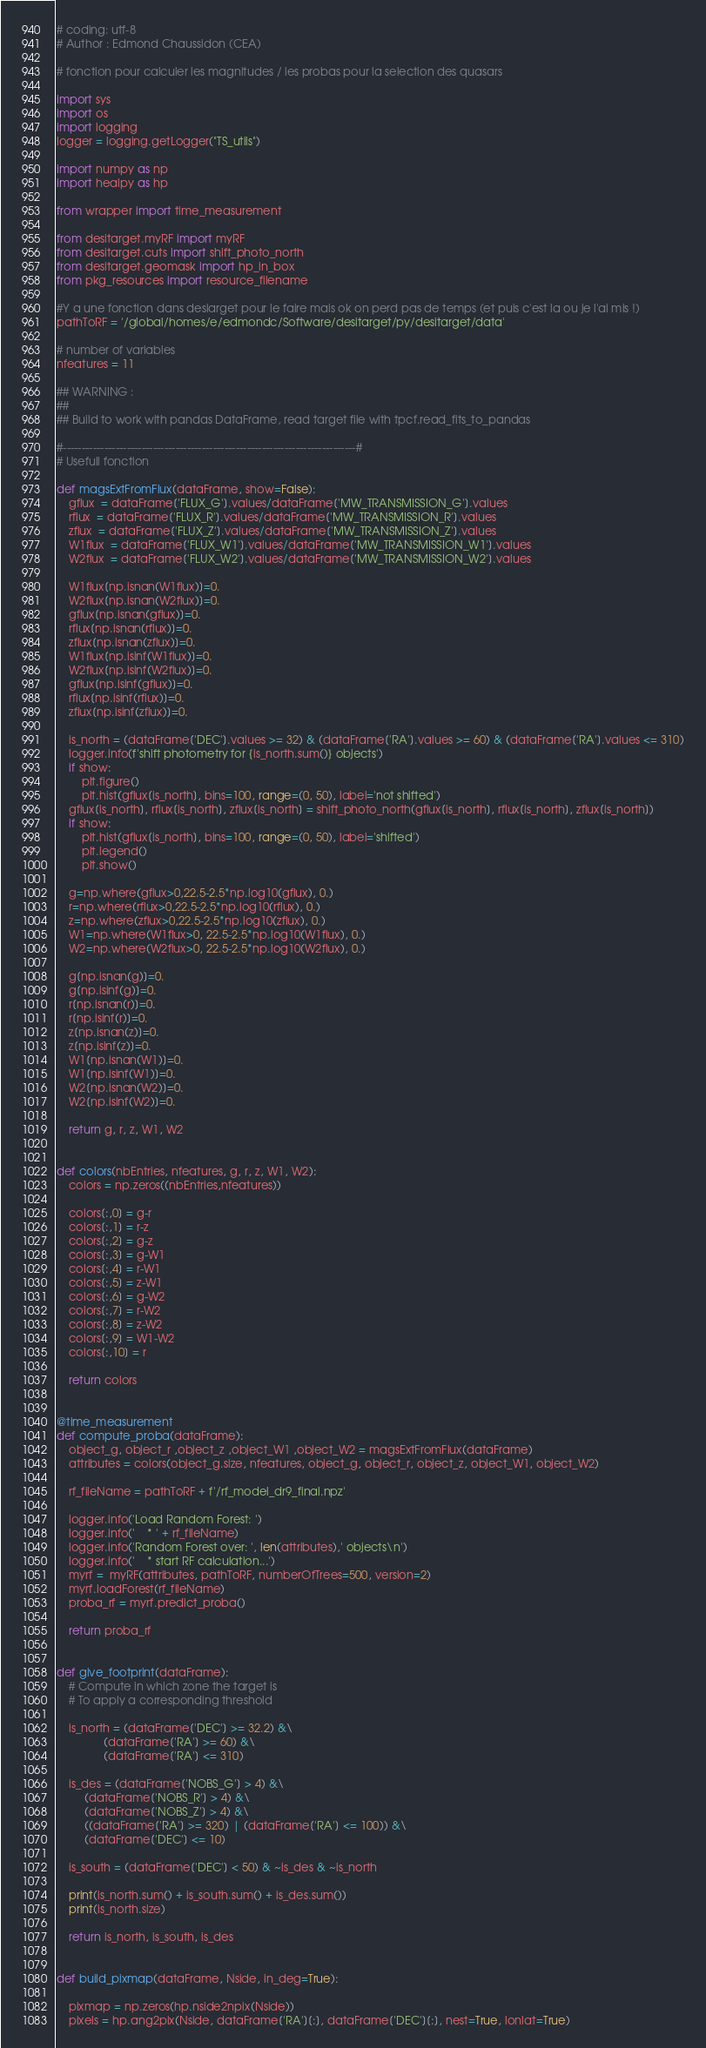Convert code to text. <code><loc_0><loc_0><loc_500><loc_500><_Python_># coding: utf-8
# Author : Edmond Chaussidon (CEA)

# fonction pour calculer les magnitudes / les probas pour la selection des quasars

import sys
import os
import logging
logger = logging.getLogger("TS_utils")

import numpy as np
import healpy as hp

from wrapper import time_measurement

from desitarget.myRF import myRF
from desitarget.cuts import shift_photo_north
from desitarget.geomask import hp_in_box
from pkg_resources import resource_filename

#Y a une fonction dans desiarget pour le faire mais ok on perd pas de temps (et puis c'est la ou je l'ai mis !)
pathToRF = '/global/homes/e/edmondc/Software/desitarget/py/desitarget/data'

# number of variables
nfeatures = 11

## WARNING :
##
## Build to work with pandas DataFrame, read target file with tpcf.read_fits_to_pandas

#------------------------------------------------------------------------------#
# Usefull fonction

def magsExtFromFlux(dataFrame, show=False):
    gflux  = dataFrame['FLUX_G'].values/dataFrame['MW_TRANSMISSION_G'].values
    rflux  = dataFrame['FLUX_R'].values/dataFrame['MW_TRANSMISSION_R'].values
    zflux  = dataFrame['FLUX_Z'].values/dataFrame['MW_TRANSMISSION_Z'].values
    W1flux  = dataFrame['FLUX_W1'].values/dataFrame['MW_TRANSMISSION_W1'].values
    W2flux  = dataFrame['FLUX_W2'].values/dataFrame['MW_TRANSMISSION_W2'].values
    
    W1flux[np.isnan(W1flux)]=0.
    W2flux[np.isnan(W2flux)]=0.
    gflux[np.isnan(gflux)]=0.
    rflux[np.isnan(rflux)]=0.
    zflux[np.isnan(zflux)]=0.
    W1flux[np.isinf(W1flux)]=0.
    W2flux[np.isinf(W2flux)]=0.
    gflux[np.isinf(gflux)]=0.
    rflux[np.isinf(rflux)]=0.
    zflux[np.isinf(zflux)]=0.
  
    is_north = (dataFrame['DEC'].values >= 32) & (dataFrame['RA'].values >= 60) & (dataFrame['RA'].values <= 310)
    logger.info(f'shift photometry for {is_north.sum()} objects')
    if show:
        plt.figure()
        plt.hist(gflux[is_north], bins=100, range=(0, 50), label='not shifted')
    gflux[is_north], rflux[is_north], zflux[is_north] = shift_photo_north(gflux[is_north], rflux[is_north], zflux[is_north])
    if show:
        plt.hist(gflux[is_north], bins=100, range=(0, 50), label='shifted')
        plt.legend()
        plt.show()

    g=np.where(gflux>0,22.5-2.5*np.log10(gflux), 0.)
    r=np.where(rflux>0,22.5-2.5*np.log10(rflux), 0.)
    z=np.where(zflux>0,22.5-2.5*np.log10(zflux), 0.)
    W1=np.where(W1flux>0, 22.5-2.5*np.log10(W1flux), 0.)
    W2=np.where(W2flux>0, 22.5-2.5*np.log10(W2flux), 0.)

    g[np.isnan(g)]=0.
    g[np.isinf(g)]=0.
    r[np.isnan(r)]=0.
    r[np.isinf(r)]=0.
    z[np.isnan(z)]=0.
    z[np.isinf(z)]=0.
    W1[np.isnan(W1)]=0.
    W1[np.isinf(W1)]=0.
    W2[np.isnan(W2)]=0.
    W2[np.isinf(W2)]=0.
    
    return g, r, z, W1, W2


def colors(nbEntries, nfeatures, g, r, z, W1, W2):
    colors = np.zeros((nbEntries,nfeatures))

    colors[:,0] = g-r
    colors[:,1] = r-z
    colors[:,2] = g-z
    colors[:,3] = g-W1
    colors[:,4] = r-W1
    colors[:,5] = z-W1
    colors[:,6] = g-W2
    colors[:,7] = r-W2
    colors[:,8] = z-W2
    colors[:,9] = W1-W2
    colors[:,10] = r

    return colors


@time_measurement
def compute_proba(dataFrame):
    object_g, object_r ,object_z ,object_W1 ,object_W2 = magsExtFromFlux(dataFrame)
    attributes = colors(object_g.size, nfeatures, object_g, object_r, object_z, object_W1, object_W2)

    rf_fileName = pathToRF + f'/rf_model_dr9_final.npz'

    logger.info('Load Random Forest: ')
    logger.info('    * ' + rf_fileName)
    logger.info('Random Forest over: ', len(attributes),' objects\n')
    logger.info('    * start RF calculation...')
    myrf =  myRF(attributes, pathToRF, numberOfTrees=500, version=2)
    myrf.loadForest(rf_fileName)
    proba_rf = myrf.predict_proba()

    return proba_rf 


def give_footprint(dataFrame):
    # Compute in which zone the target is
    # To apply a corresponding threshold
    
    is_north = (dataFrame['DEC'] >= 32.2) &\
               (dataFrame['RA'] >= 60) &\
               (dataFrame['RA'] <= 310)
    
    is_des = (dataFrame['NOBS_G'] > 4) &\
         (dataFrame['NOBS_R'] > 4) &\
         (dataFrame['NOBS_Z'] > 4) &\
         ((dataFrame['RA'] >= 320) | (dataFrame['RA'] <= 100)) &\
         (dataFrame['DEC'] <= 10)
    
    is_south = (dataFrame['DEC'] < 50) & ~is_des & ~is_north
    
    print(is_north.sum() + is_south.sum() + is_des.sum())
    print(is_north.size)
    
    return is_north, is_south, is_des


def build_pixmap(dataFrame, Nside, in_deg=True):

    pixmap = np.zeros(hp.nside2npix(Nside))
    pixels = hp.ang2pix(Nside, dataFrame['RA'][:], dataFrame['DEC'][:], nest=True, lonlat=True)</code> 